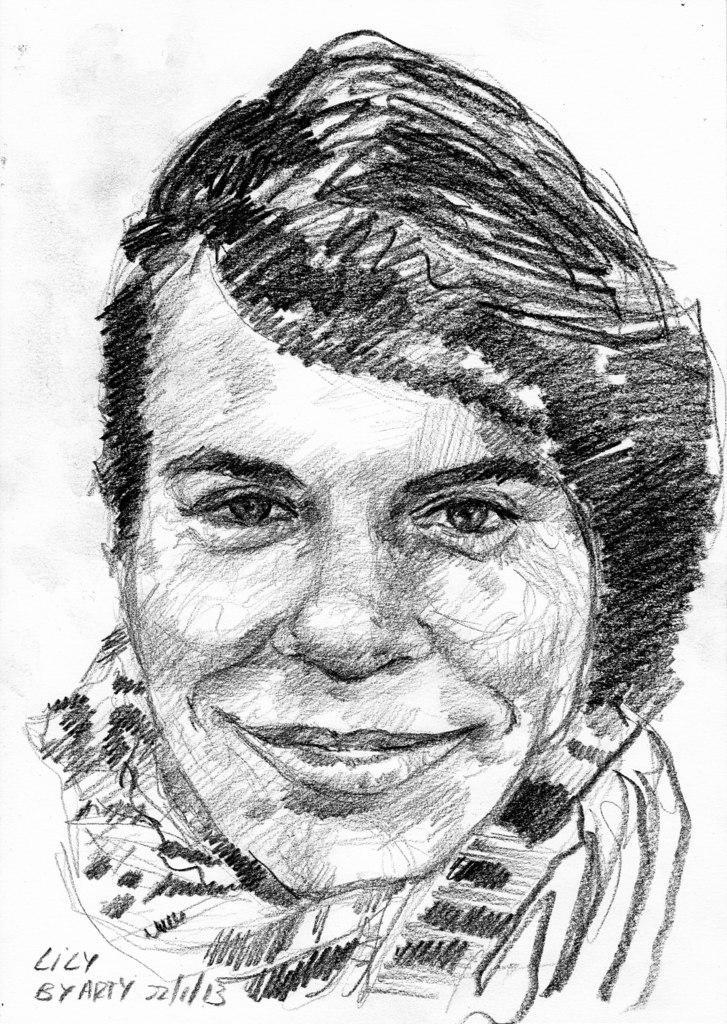Describe this image in one or two sentences. In this image there is a drawing of a person. Left bottom there is some text. 